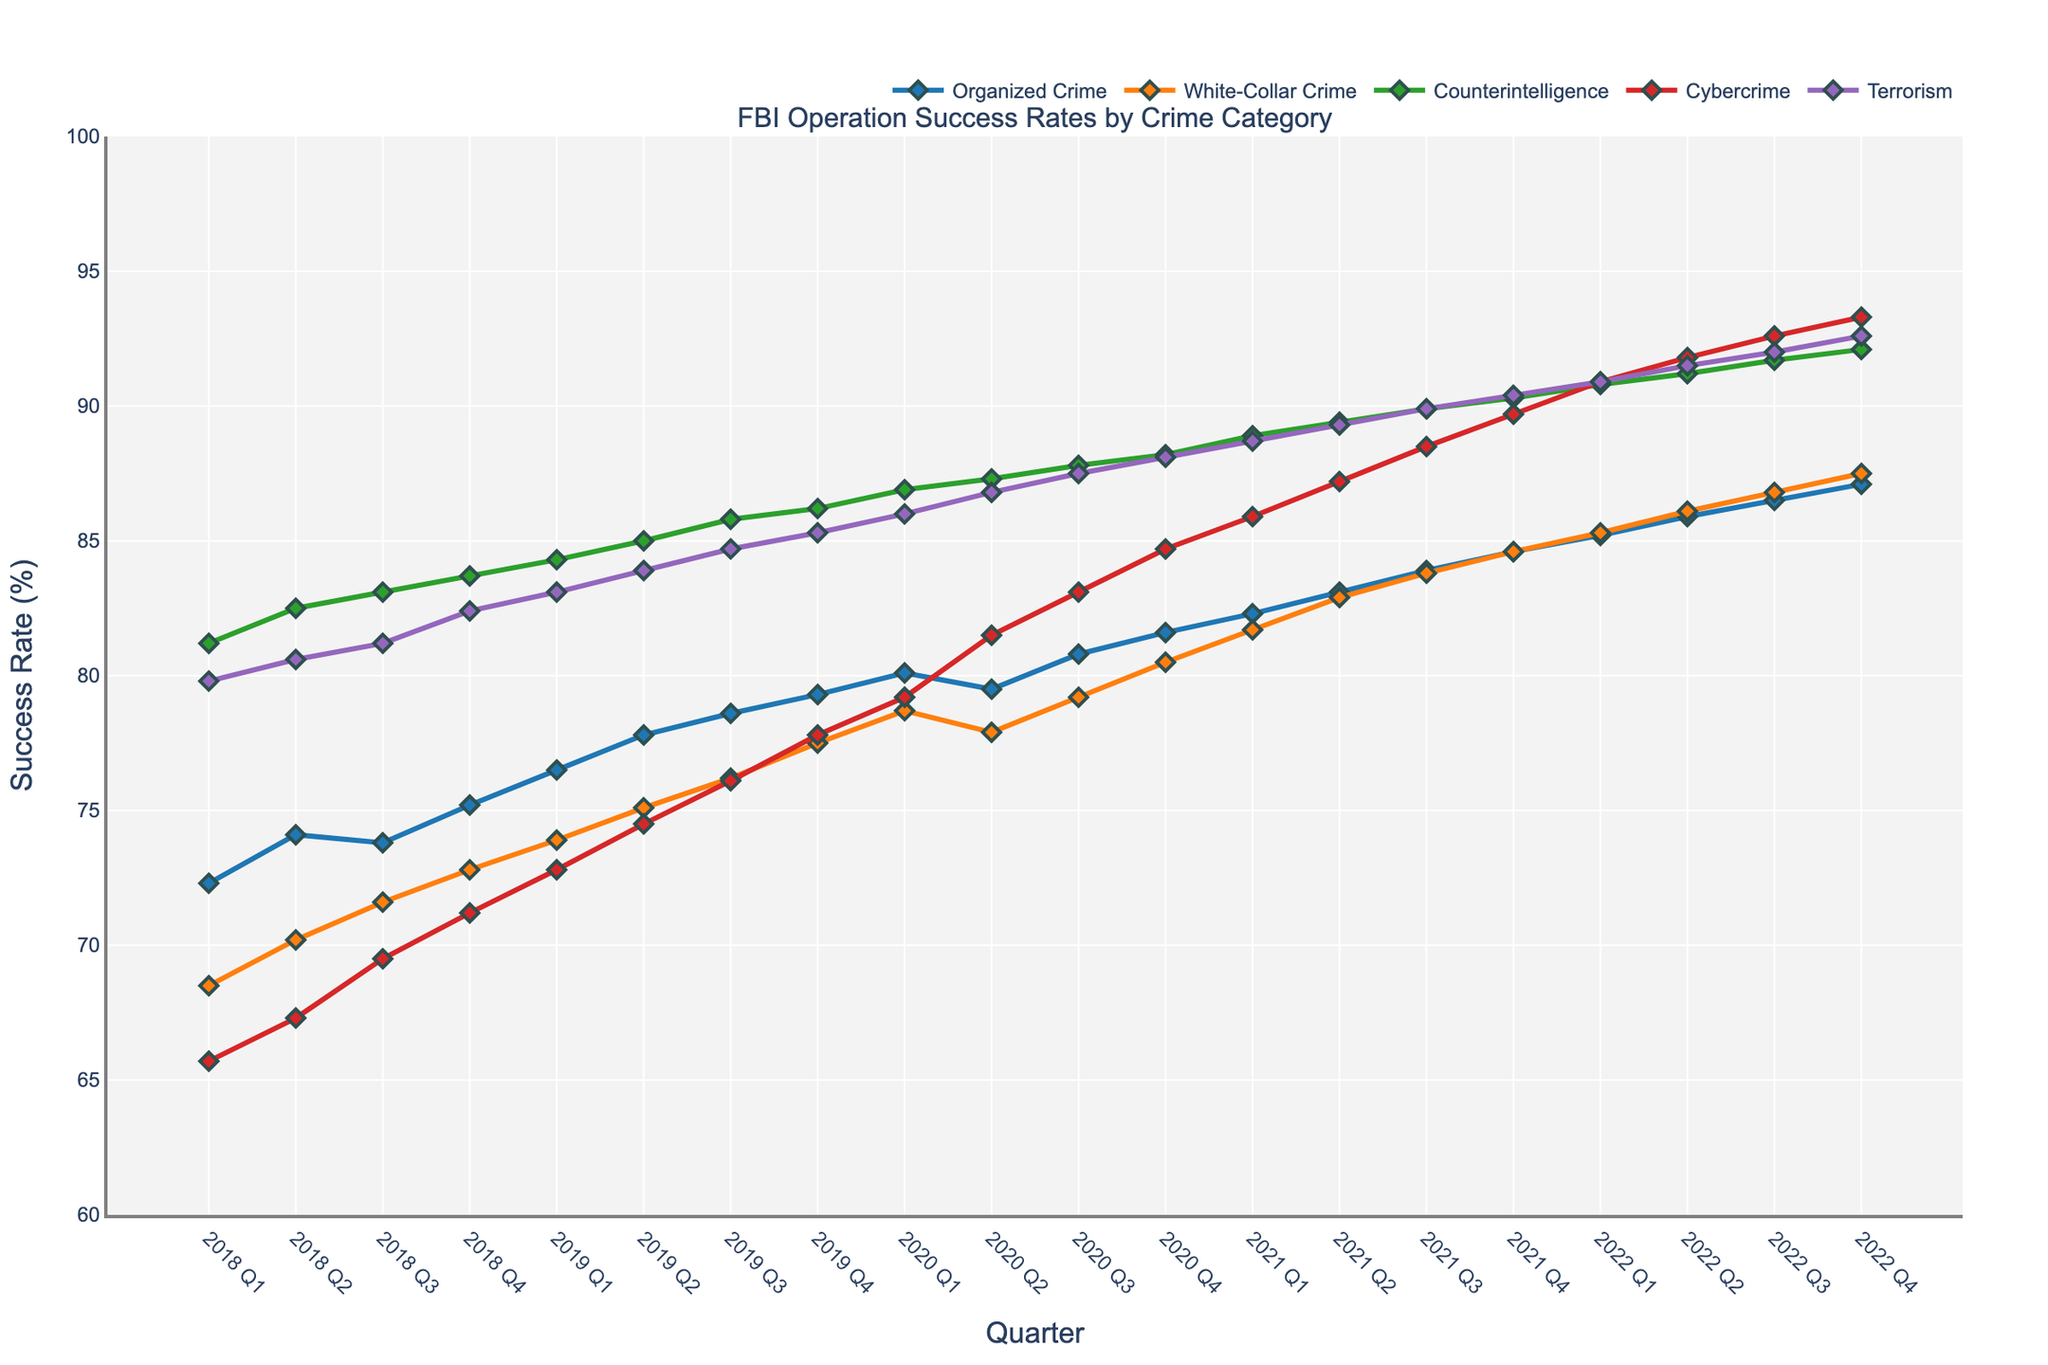What is the overall trend for the success rates of Counterintelligence operations over the five-year period? To determine the trend, look at the line representing Counterintelligence operations. This line starts at 81.2% in 2018 Q1 and rises to 92.1% by 2022 Q4. The overall direction of this line is upward, indicating an increasing trend.
Answer: Increasing Which crime category has shown the most significant improvement in success rate over the five years? To find the most significant improvement, calculate the difference between the final and initial values for each category. The increases are: Organized Crime (87.1-72.3=14.8), White-Collar Crime (87.5-68.5=19.0), Counterintelligence (92.1-81.2=10.9), Cybercrime (93.3-65.7=27.6), Terrorism (92.6-79.8=12.8). Cybercrime shows the largest improvement.
Answer: Cybercrime During which quarter did White-Collar Crime achieve a success rate equating to 75% for the first time? Look for the first instance in the timeline where the White-Collar Crime line hits 75%. From the data, this occurs between 2019 Q1 and 2019 Q2, but specifically in 2019 Q2.
Answer: 2019 Q2 Compare the success rate of Organized Crime and Cybercrime in 2020 Q2. Which was greater and by how much? The success rate for Organized Crime in 2020 Q2 is 79.5% and for Cybercrime, it is 81.5%. Subtract the smaller value from the larger one to find the difference: 81.5 - 79.5 = 2.0. Cybercrime's success rate is greater by 2.0%.
Answer: Cybercrime, 2.0% What is the average success rate of Terrorism operations in the year 2021? To find the average for 2021, sum the figures for all four quarters and then divide by 4. The values are 88.7%, 89.3%, 89.9%, 90.4%. (88.7 + 89.3 + 89.9 + 90.4)/4 = 358.3/4 = 89.575%.
Answer: 89.575% What happens to the success rate of Cybercrime from 2020 Q3 to 2022 Q1? The success rates for Cybercrime in these quarters are 83.1% and 90.9% respectively. Comparing the two values, Cybercrime shows a consistent upward trend from 83.1% to 90.9% over these quarters.
Answer: It increases Identify the quarter with the maximum success rate for any crime category and specify the category. Reviewing the data shows that the highest value is 93.3%, which belongs to Cybercrime in 2022 Q4.
Answer: Cybercrime, 2022 Q4 Which crime category consistently shows above 80% success rate from the beginning to the end of the timeline? Assess each category's initial and final values. Counterintelligence starts at 81.2% in 2018 Q1 and remains above 80% throughout the five-year period, ending at 92.1% in 2022 Q4.
Answer: Counterintelligence What are the success rate differences between Terrorism in 2018 Q1 and 2022 Q4? Identify the rates at these points; Terrorism starts at 79.8% in 2018 Q1 and ends at 92.6% in 2022 Q4. The difference is 92.6 - 79.8 = 12.8.
Answer: 12.8 Among the five crime categories, which one had the least variability in success rates over the entire timeline? Variability can be assessed by looking at the smallest range (difference between maximum and minimum values). Calculating for each: Organized Crime (87.1-72.3=14.8), White-Collar Crime (87.5-68.5=19.0), Counterintelligence (92.1-81.2=10.9), Cybercrime (93.3-65.7=27.6), Terrorism (92.6-79.8=12.8). Counterintelligence has the least variability.
Answer: Counterintelligence 